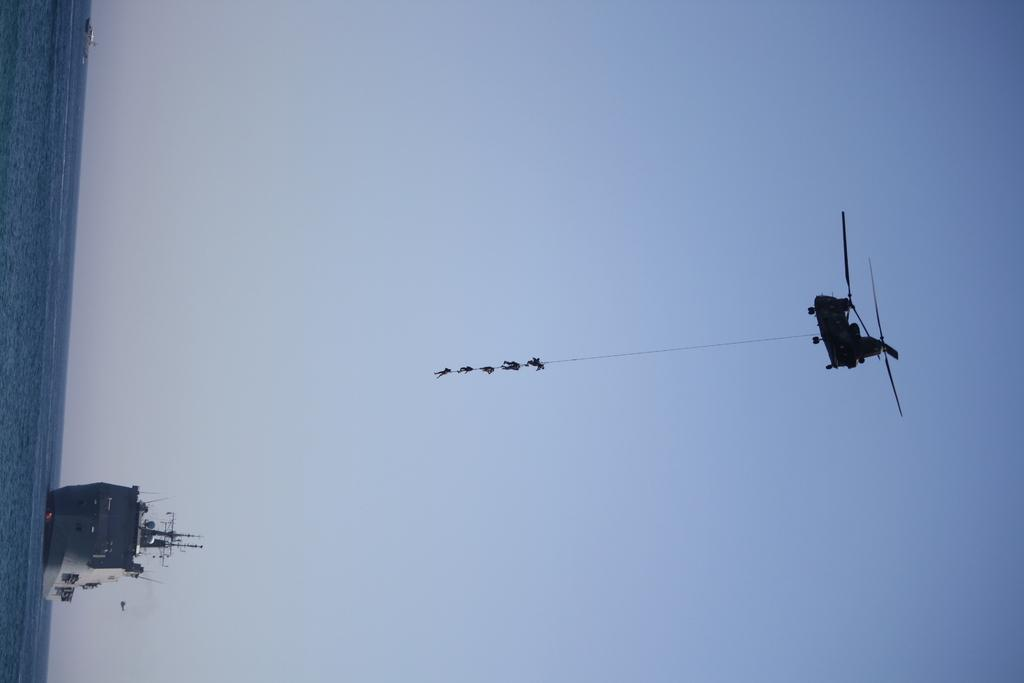What type of vehicle is flying in the image? There is a flying jet in the image. What are the people doing in the image? People are hanging from a rope in the image. What body of water is visible in the image? There is a ship in the water in the image. What color is the sky in the image? The sky is pale blue in the image. Where is the carriage located in the image? There is no carriage present in the image. What type of shop can be seen in the image? There is no shop present in the image. 